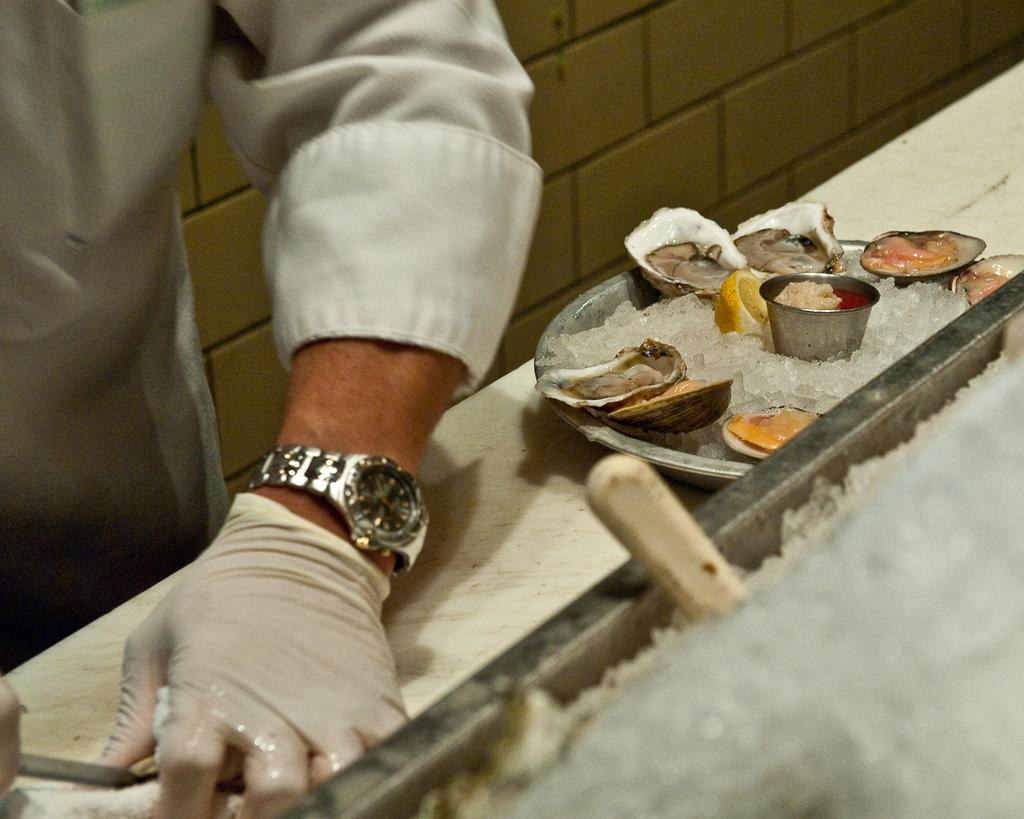Who is present in the image? There is a man in the image. What is the man wearing on his hand? The man is wearing a glove. What is in front of the man? There is ice in front of the man. What else can be seen on the plate in front of the man? There are other items on a plate in front of the man. What accessory is the man wearing on his wrist? The man is wearing a wristwatch. What type of behavior is the man exhibiting with the banana in the image? There is no banana present in the image, so it is not possible to determine any behavior related to a banana. 